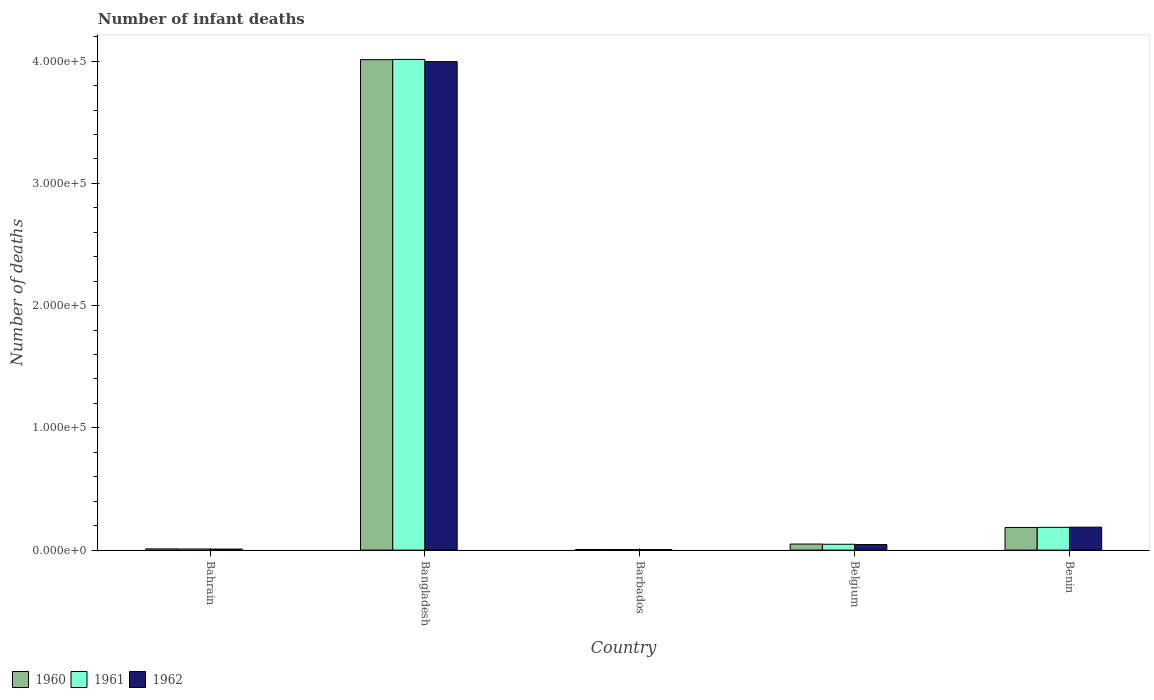How many different coloured bars are there?
Offer a very short reply. 3. How many groups of bars are there?
Give a very brief answer. 5. Are the number of bars per tick equal to the number of legend labels?
Ensure brevity in your answer.  Yes. Are the number of bars on each tick of the X-axis equal?
Keep it short and to the point. Yes. How many bars are there on the 5th tick from the right?
Make the answer very short. 3. What is the label of the 2nd group of bars from the left?
Provide a succinct answer. Bangladesh. What is the number of infant deaths in 1960 in Belgium?
Give a very brief answer. 4942. Across all countries, what is the maximum number of infant deaths in 1962?
Your answer should be very brief. 4.00e+05. Across all countries, what is the minimum number of infant deaths in 1960?
Offer a terse response. 518. In which country was the number of infant deaths in 1962 minimum?
Offer a very short reply. Barbados. What is the total number of infant deaths in 1961 in the graph?
Offer a terse response. 4.26e+05. What is the difference between the number of infant deaths in 1962 in Bangladesh and that in Benin?
Ensure brevity in your answer.  3.81e+05. What is the difference between the number of infant deaths in 1960 in Benin and the number of infant deaths in 1961 in Bahrain?
Offer a terse response. 1.76e+04. What is the average number of infant deaths in 1962 per country?
Provide a short and direct response. 8.49e+04. What is the difference between the number of infant deaths of/in 1962 and number of infant deaths of/in 1960 in Barbados?
Provide a succinct answer. -67. What is the ratio of the number of infant deaths in 1960 in Bahrain to that in Benin?
Give a very brief answer. 0.05. Is the number of infant deaths in 1961 in Bahrain less than that in Benin?
Your answer should be compact. Yes. Is the difference between the number of infant deaths in 1962 in Bahrain and Belgium greater than the difference between the number of infant deaths in 1960 in Bahrain and Belgium?
Make the answer very short. Yes. What is the difference between the highest and the second highest number of infant deaths in 1962?
Your answer should be very brief. -1.42e+04. What is the difference between the highest and the lowest number of infant deaths in 1960?
Offer a very short reply. 4.01e+05. Is the sum of the number of infant deaths in 1961 in Bahrain and Belgium greater than the maximum number of infant deaths in 1962 across all countries?
Provide a succinct answer. No. Is it the case that in every country, the sum of the number of infant deaths in 1961 and number of infant deaths in 1960 is greater than the number of infant deaths in 1962?
Provide a succinct answer. Yes. How many bars are there?
Offer a very short reply. 15. Are all the bars in the graph horizontal?
Your answer should be compact. No. How many countries are there in the graph?
Offer a terse response. 5. What is the difference between two consecutive major ticks on the Y-axis?
Offer a very short reply. 1.00e+05. Does the graph contain grids?
Offer a very short reply. No. Where does the legend appear in the graph?
Give a very brief answer. Bottom left. How many legend labels are there?
Provide a succinct answer. 3. What is the title of the graph?
Ensure brevity in your answer.  Number of infant deaths. What is the label or title of the X-axis?
Offer a very short reply. Country. What is the label or title of the Y-axis?
Your answer should be compact. Number of deaths. What is the Number of deaths in 1960 in Bahrain?
Your response must be concise. 990. What is the Number of deaths of 1961 in Bahrain?
Give a very brief answer. 913. What is the Number of deaths of 1962 in Bahrain?
Offer a terse response. 828. What is the Number of deaths in 1960 in Bangladesh?
Ensure brevity in your answer.  4.01e+05. What is the Number of deaths in 1961 in Bangladesh?
Your answer should be very brief. 4.01e+05. What is the Number of deaths in 1962 in Bangladesh?
Provide a short and direct response. 4.00e+05. What is the Number of deaths in 1960 in Barbados?
Provide a short and direct response. 518. What is the Number of deaths of 1961 in Barbados?
Offer a terse response. 483. What is the Number of deaths of 1962 in Barbados?
Provide a succinct answer. 451. What is the Number of deaths in 1960 in Belgium?
Your answer should be compact. 4942. What is the Number of deaths in 1961 in Belgium?
Provide a succinct answer. 4783. What is the Number of deaths in 1962 in Belgium?
Keep it short and to the point. 4571. What is the Number of deaths of 1960 in Benin?
Your response must be concise. 1.85e+04. What is the Number of deaths in 1961 in Benin?
Keep it short and to the point. 1.86e+04. What is the Number of deaths of 1962 in Benin?
Provide a short and direct response. 1.88e+04. Across all countries, what is the maximum Number of deaths in 1960?
Offer a terse response. 4.01e+05. Across all countries, what is the maximum Number of deaths in 1961?
Give a very brief answer. 4.01e+05. Across all countries, what is the maximum Number of deaths in 1962?
Offer a very short reply. 4.00e+05. Across all countries, what is the minimum Number of deaths in 1960?
Give a very brief answer. 518. Across all countries, what is the minimum Number of deaths of 1961?
Offer a very short reply. 483. Across all countries, what is the minimum Number of deaths in 1962?
Your answer should be very brief. 451. What is the total Number of deaths of 1960 in the graph?
Ensure brevity in your answer.  4.26e+05. What is the total Number of deaths of 1961 in the graph?
Make the answer very short. 4.26e+05. What is the total Number of deaths of 1962 in the graph?
Offer a terse response. 4.24e+05. What is the difference between the Number of deaths in 1960 in Bahrain and that in Bangladesh?
Make the answer very short. -4.00e+05. What is the difference between the Number of deaths in 1961 in Bahrain and that in Bangladesh?
Your response must be concise. -4.01e+05. What is the difference between the Number of deaths of 1962 in Bahrain and that in Bangladesh?
Your response must be concise. -3.99e+05. What is the difference between the Number of deaths in 1960 in Bahrain and that in Barbados?
Make the answer very short. 472. What is the difference between the Number of deaths of 1961 in Bahrain and that in Barbados?
Make the answer very short. 430. What is the difference between the Number of deaths of 1962 in Bahrain and that in Barbados?
Keep it short and to the point. 377. What is the difference between the Number of deaths in 1960 in Bahrain and that in Belgium?
Keep it short and to the point. -3952. What is the difference between the Number of deaths in 1961 in Bahrain and that in Belgium?
Make the answer very short. -3870. What is the difference between the Number of deaths of 1962 in Bahrain and that in Belgium?
Offer a terse response. -3743. What is the difference between the Number of deaths in 1960 in Bahrain and that in Benin?
Keep it short and to the point. -1.75e+04. What is the difference between the Number of deaths in 1961 in Bahrain and that in Benin?
Make the answer very short. -1.77e+04. What is the difference between the Number of deaths in 1962 in Bahrain and that in Benin?
Keep it short and to the point. -1.79e+04. What is the difference between the Number of deaths in 1960 in Bangladesh and that in Barbados?
Provide a succinct answer. 4.01e+05. What is the difference between the Number of deaths of 1961 in Bangladesh and that in Barbados?
Your response must be concise. 4.01e+05. What is the difference between the Number of deaths of 1962 in Bangladesh and that in Barbados?
Ensure brevity in your answer.  3.99e+05. What is the difference between the Number of deaths of 1960 in Bangladesh and that in Belgium?
Give a very brief answer. 3.96e+05. What is the difference between the Number of deaths in 1961 in Bangladesh and that in Belgium?
Ensure brevity in your answer.  3.97e+05. What is the difference between the Number of deaths of 1962 in Bangladesh and that in Belgium?
Ensure brevity in your answer.  3.95e+05. What is the difference between the Number of deaths of 1960 in Bangladesh and that in Benin?
Your answer should be compact. 3.83e+05. What is the difference between the Number of deaths in 1961 in Bangladesh and that in Benin?
Provide a succinct answer. 3.83e+05. What is the difference between the Number of deaths of 1962 in Bangladesh and that in Benin?
Give a very brief answer. 3.81e+05. What is the difference between the Number of deaths in 1960 in Barbados and that in Belgium?
Keep it short and to the point. -4424. What is the difference between the Number of deaths of 1961 in Barbados and that in Belgium?
Keep it short and to the point. -4300. What is the difference between the Number of deaths of 1962 in Barbados and that in Belgium?
Offer a terse response. -4120. What is the difference between the Number of deaths of 1960 in Barbados and that in Benin?
Keep it short and to the point. -1.80e+04. What is the difference between the Number of deaths in 1961 in Barbados and that in Benin?
Your answer should be compact. -1.81e+04. What is the difference between the Number of deaths of 1962 in Barbados and that in Benin?
Your answer should be very brief. -1.83e+04. What is the difference between the Number of deaths in 1960 in Belgium and that in Benin?
Keep it short and to the point. -1.36e+04. What is the difference between the Number of deaths of 1961 in Belgium and that in Benin?
Your response must be concise. -1.38e+04. What is the difference between the Number of deaths in 1962 in Belgium and that in Benin?
Offer a very short reply. -1.42e+04. What is the difference between the Number of deaths in 1960 in Bahrain and the Number of deaths in 1961 in Bangladesh?
Give a very brief answer. -4.00e+05. What is the difference between the Number of deaths in 1960 in Bahrain and the Number of deaths in 1962 in Bangladesh?
Make the answer very short. -3.99e+05. What is the difference between the Number of deaths in 1961 in Bahrain and the Number of deaths in 1962 in Bangladesh?
Your answer should be very brief. -3.99e+05. What is the difference between the Number of deaths in 1960 in Bahrain and the Number of deaths in 1961 in Barbados?
Make the answer very short. 507. What is the difference between the Number of deaths of 1960 in Bahrain and the Number of deaths of 1962 in Barbados?
Provide a short and direct response. 539. What is the difference between the Number of deaths of 1961 in Bahrain and the Number of deaths of 1962 in Barbados?
Your answer should be compact. 462. What is the difference between the Number of deaths of 1960 in Bahrain and the Number of deaths of 1961 in Belgium?
Keep it short and to the point. -3793. What is the difference between the Number of deaths in 1960 in Bahrain and the Number of deaths in 1962 in Belgium?
Give a very brief answer. -3581. What is the difference between the Number of deaths of 1961 in Bahrain and the Number of deaths of 1962 in Belgium?
Offer a terse response. -3658. What is the difference between the Number of deaths in 1960 in Bahrain and the Number of deaths in 1961 in Benin?
Make the answer very short. -1.76e+04. What is the difference between the Number of deaths in 1960 in Bahrain and the Number of deaths in 1962 in Benin?
Your response must be concise. -1.78e+04. What is the difference between the Number of deaths in 1961 in Bahrain and the Number of deaths in 1962 in Benin?
Your response must be concise. -1.79e+04. What is the difference between the Number of deaths of 1960 in Bangladesh and the Number of deaths of 1961 in Barbados?
Make the answer very short. 4.01e+05. What is the difference between the Number of deaths of 1960 in Bangladesh and the Number of deaths of 1962 in Barbados?
Offer a terse response. 4.01e+05. What is the difference between the Number of deaths of 1961 in Bangladesh and the Number of deaths of 1962 in Barbados?
Keep it short and to the point. 4.01e+05. What is the difference between the Number of deaths of 1960 in Bangladesh and the Number of deaths of 1961 in Belgium?
Offer a terse response. 3.96e+05. What is the difference between the Number of deaths in 1960 in Bangladesh and the Number of deaths in 1962 in Belgium?
Make the answer very short. 3.97e+05. What is the difference between the Number of deaths in 1961 in Bangladesh and the Number of deaths in 1962 in Belgium?
Offer a very short reply. 3.97e+05. What is the difference between the Number of deaths in 1960 in Bangladesh and the Number of deaths in 1961 in Benin?
Offer a terse response. 3.83e+05. What is the difference between the Number of deaths in 1960 in Bangladesh and the Number of deaths in 1962 in Benin?
Your answer should be compact. 3.82e+05. What is the difference between the Number of deaths of 1961 in Bangladesh and the Number of deaths of 1962 in Benin?
Give a very brief answer. 3.83e+05. What is the difference between the Number of deaths in 1960 in Barbados and the Number of deaths in 1961 in Belgium?
Your response must be concise. -4265. What is the difference between the Number of deaths of 1960 in Barbados and the Number of deaths of 1962 in Belgium?
Provide a succinct answer. -4053. What is the difference between the Number of deaths in 1961 in Barbados and the Number of deaths in 1962 in Belgium?
Offer a very short reply. -4088. What is the difference between the Number of deaths in 1960 in Barbados and the Number of deaths in 1961 in Benin?
Give a very brief answer. -1.81e+04. What is the difference between the Number of deaths in 1960 in Barbados and the Number of deaths in 1962 in Benin?
Give a very brief answer. -1.83e+04. What is the difference between the Number of deaths of 1961 in Barbados and the Number of deaths of 1962 in Benin?
Your answer should be compact. -1.83e+04. What is the difference between the Number of deaths in 1960 in Belgium and the Number of deaths in 1961 in Benin?
Offer a very short reply. -1.37e+04. What is the difference between the Number of deaths of 1960 in Belgium and the Number of deaths of 1962 in Benin?
Offer a very short reply. -1.38e+04. What is the difference between the Number of deaths of 1961 in Belgium and the Number of deaths of 1962 in Benin?
Your answer should be very brief. -1.40e+04. What is the average Number of deaths in 1960 per country?
Ensure brevity in your answer.  8.52e+04. What is the average Number of deaths in 1961 per country?
Your response must be concise. 8.53e+04. What is the average Number of deaths in 1962 per country?
Keep it short and to the point. 8.49e+04. What is the difference between the Number of deaths in 1960 and Number of deaths in 1961 in Bahrain?
Your answer should be compact. 77. What is the difference between the Number of deaths in 1960 and Number of deaths in 1962 in Bahrain?
Offer a terse response. 162. What is the difference between the Number of deaths of 1960 and Number of deaths of 1961 in Bangladesh?
Ensure brevity in your answer.  -216. What is the difference between the Number of deaths of 1960 and Number of deaths of 1962 in Bangladesh?
Provide a succinct answer. 1591. What is the difference between the Number of deaths in 1961 and Number of deaths in 1962 in Bangladesh?
Provide a short and direct response. 1807. What is the difference between the Number of deaths of 1960 and Number of deaths of 1961 in Belgium?
Provide a short and direct response. 159. What is the difference between the Number of deaths in 1960 and Number of deaths in 1962 in Belgium?
Provide a succinct answer. 371. What is the difference between the Number of deaths in 1961 and Number of deaths in 1962 in Belgium?
Provide a short and direct response. 212. What is the difference between the Number of deaths of 1960 and Number of deaths of 1961 in Benin?
Offer a terse response. -87. What is the difference between the Number of deaths of 1960 and Number of deaths of 1962 in Benin?
Make the answer very short. -242. What is the difference between the Number of deaths of 1961 and Number of deaths of 1962 in Benin?
Your answer should be very brief. -155. What is the ratio of the Number of deaths of 1960 in Bahrain to that in Bangladesh?
Provide a short and direct response. 0. What is the ratio of the Number of deaths of 1961 in Bahrain to that in Bangladesh?
Give a very brief answer. 0. What is the ratio of the Number of deaths of 1962 in Bahrain to that in Bangladesh?
Keep it short and to the point. 0. What is the ratio of the Number of deaths in 1960 in Bahrain to that in Barbados?
Keep it short and to the point. 1.91. What is the ratio of the Number of deaths in 1961 in Bahrain to that in Barbados?
Offer a terse response. 1.89. What is the ratio of the Number of deaths in 1962 in Bahrain to that in Barbados?
Provide a succinct answer. 1.84. What is the ratio of the Number of deaths in 1960 in Bahrain to that in Belgium?
Your answer should be compact. 0.2. What is the ratio of the Number of deaths in 1961 in Bahrain to that in Belgium?
Offer a terse response. 0.19. What is the ratio of the Number of deaths of 1962 in Bahrain to that in Belgium?
Your response must be concise. 0.18. What is the ratio of the Number of deaths in 1960 in Bahrain to that in Benin?
Your response must be concise. 0.05. What is the ratio of the Number of deaths in 1961 in Bahrain to that in Benin?
Your answer should be very brief. 0.05. What is the ratio of the Number of deaths in 1962 in Bahrain to that in Benin?
Offer a terse response. 0.04. What is the ratio of the Number of deaths in 1960 in Bangladesh to that in Barbados?
Make the answer very short. 774.62. What is the ratio of the Number of deaths of 1961 in Bangladesh to that in Barbados?
Ensure brevity in your answer.  831.2. What is the ratio of the Number of deaths in 1962 in Bangladesh to that in Barbados?
Your answer should be compact. 886.17. What is the ratio of the Number of deaths of 1960 in Bangladesh to that in Belgium?
Make the answer very short. 81.19. What is the ratio of the Number of deaths of 1961 in Bangladesh to that in Belgium?
Offer a very short reply. 83.94. What is the ratio of the Number of deaths in 1962 in Bangladesh to that in Belgium?
Provide a succinct answer. 87.43. What is the ratio of the Number of deaths of 1960 in Bangladesh to that in Benin?
Your answer should be compact. 21.65. What is the ratio of the Number of deaths of 1961 in Bangladesh to that in Benin?
Provide a short and direct response. 21.56. What is the ratio of the Number of deaths of 1962 in Bangladesh to that in Benin?
Your answer should be very brief. 21.29. What is the ratio of the Number of deaths of 1960 in Barbados to that in Belgium?
Your answer should be very brief. 0.1. What is the ratio of the Number of deaths in 1961 in Barbados to that in Belgium?
Your answer should be very brief. 0.1. What is the ratio of the Number of deaths of 1962 in Barbados to that in Belgium?
Offer a terse response. 0.1. What is the ratio of the Number of deaths of 1960 in Barbados to that in Benin?
Ensure brevity in your answer.  0.03. What is the ratio of the Number of deaths in 1961 in Barbados to that in Benin?
Provide a succinct answer. 0.03. What is the ratio of the Number of deaths of 1962 in Barbados to that in Benin?
Your response must be concise. 0.02. What is the ratio of the Number of deaths in 1960 in Belgium to that in Benin?
Ensure brevity in your answer.  0.27. What is the ratio of the Number of deaths of 1961 in Belgium to that in Benin?
Make the answer very short. 0.26. What is the ratio of the Number of deaths in 1962 in Belgium to that in Benin?
Provide a short and direct response. 0.24. What is the difference between the highest and the second highest Number of deaths in 1960?
Your answer should be very brief. 3.83e+05. What is the difference between the highest and the second highest Number of deaths in 1961?
Your answer should be compact. 3.83e+05. What is the difference between the highest and the second highest Number of deaths in 1962?
Your answer should be very brief. 3.81e+05. What is the difference between the highest and the lowest Number of deaths of 1960?
Your answer should be very brief. 4.01e+05. What is the difference between the highest and the lowest Number of deaths of 1961?
Provide a succinct answer. 4.01e+05. What is the difference between the highest and the lowest Number of deaths in 1962?
Give a very brief answer. 3.99e+05. 